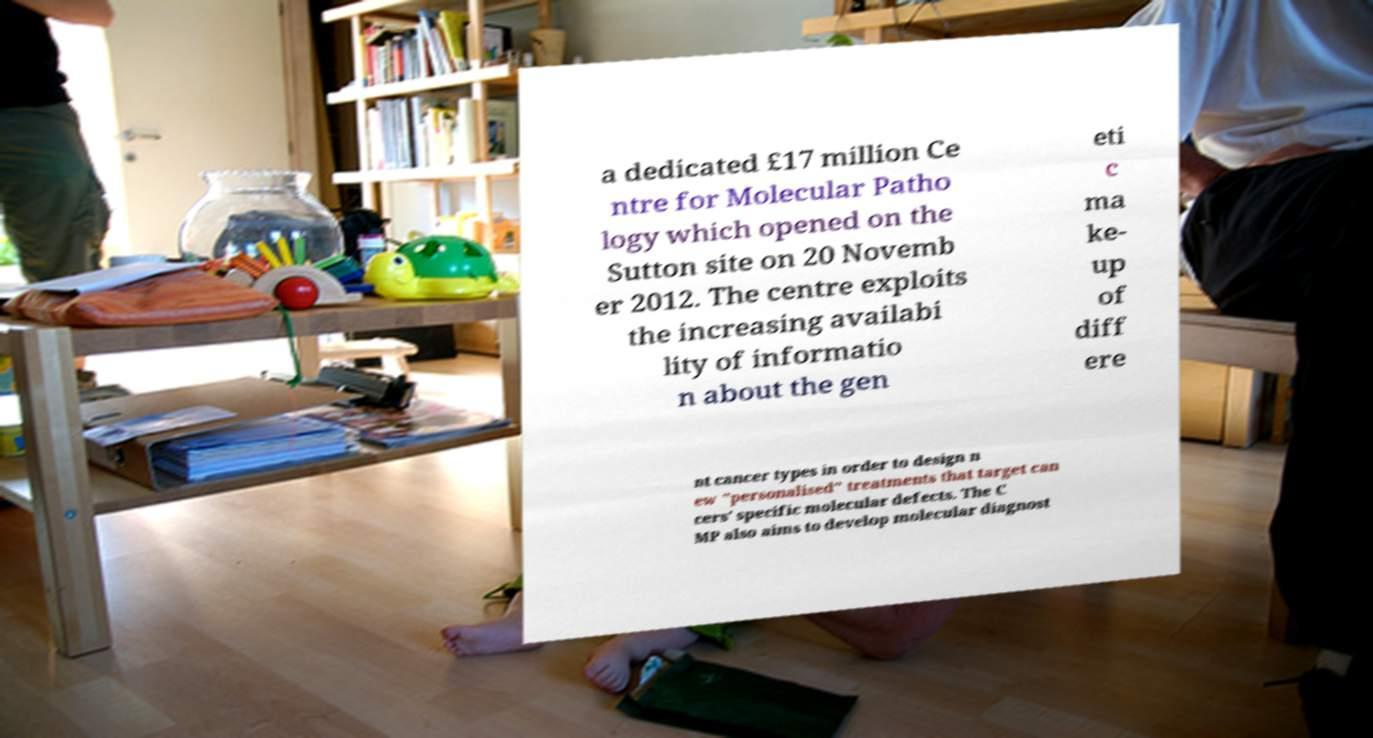What messages or text are displayed in this image? I need them in a readable, typed format. a dedicated £17 million Ce ntre for Molecular Patho logy which opened on the Sutton site on 20 Novemb er 2012. The centre exploits the increasing availabi lity of informatio n about the gen eti c ma ke- up of diff ere nt cancer types in order to design n ew "personalised" treatments that target can cers' specific molecular defects. The C MP also aims to develop molecular diagnost 